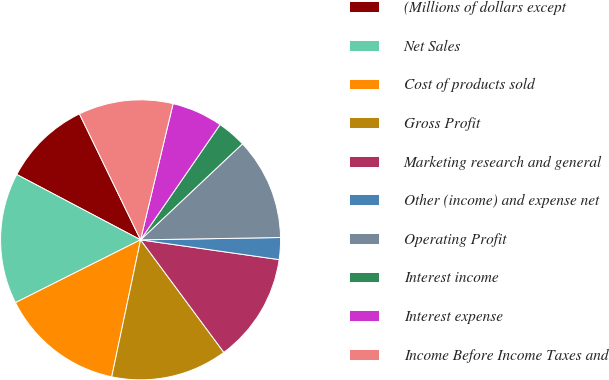Convert chart. <chart><loc_0><loc_0><loc_500><loc_500><pie_chart><fcel>(Millions of dollars except<fcel>Net Sales<fcel>Cost of products sold<fcel>Gross Profit<fcel>Marketing research and general<fcel>Other (income) and expense net<fcel>Operating Profit<fcel>Interest income<fcel>Interest expense<fcel>Income Before Income Taxes and<nl><fcel>10.08%<fcel>15.13%<fcel>14.29%<fcel>13.44%<fcel>12.6%<fcel>2.52%<fcel>11.76%<fcel>3.36%<fcel>5.88%<fcel>10.92%<nl></chart> 